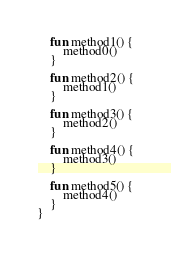Convert code to text. <code><loc_0><loc_0><loc_500><loc_500><_Kotlin_>
    fun method1() {
        method0()
    }

    fun method2() {
        method1()
    }

    fun method3() {
        method2()
    }

    fun method4() {
        method3()
    }

    fun method5() {
        method4()
    }
}
</code> 